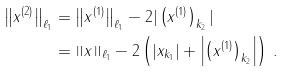<formula> <loc_0><loc_0><loc_500><loc_500>\left \| x ^ { ( 2 ) } \right \| _ { \ell _ { 1 } } & = \left \| x ^ { ( 1 ) } \right \| _ { \ell _ { 1 } } - 2 | \left ( x ^ { ( 1 ) } \right ) _ { k _ { 2 } } | \\ & = \left \| x \right \| _ { \ell _ { 1 } } - 2 \left ( | x _ { k _ { 1 } } | + \left | \left ( x ^ { ( 1 ) } \right ) _ { k _ { 2 } } \right | \right ) \, .</formula> 